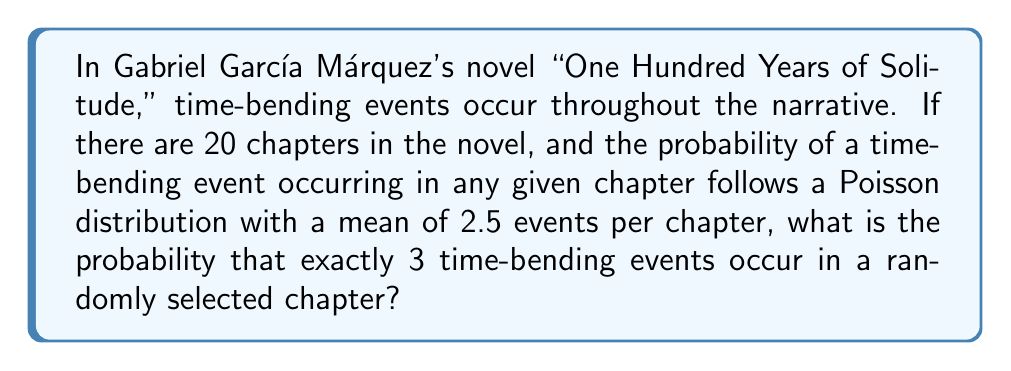What is the answer to this math problem? To solve this problem, we need to use the Poisson distribution formula:

$$ P(X = k) = \frac{e^{-\lambda} \lambda^k}{k!} $$

Where:
$\lambda$ = mean number of events per interval (in this case, per chapter)
$k$ = number of events we're interested in
$e$ = Euler's number (approximately 2.71828)

Given:
$\lambda = 2.5$
$k = 3$

Let's plug these values into the formula:

$$ P(X = 3) = \frac{e^{-2.5} (2.5)^3}{3!} $$

Step 1: Calculate $e^{-2.5}$
$e^{-2.5} \approx 0.0820$

Step 2: Calculate $(2.5)^3$
$(2.5)^3 = 15.625$

Step 3: Calculate $3!$
$3! = 3 \times 2 \times 1 = 6$

Step 4: Put it all together
$$ P(X = 3) = \frac{0.0820 \times 15.625}{6} \approx 0.2138 $$

Therefore, the probability of exactly 3 time-bending events occurring in a randomly selected chapter is approximately 0.2138 or 21.38%.
Answer: $0.2138$ or $21.38\%$ 